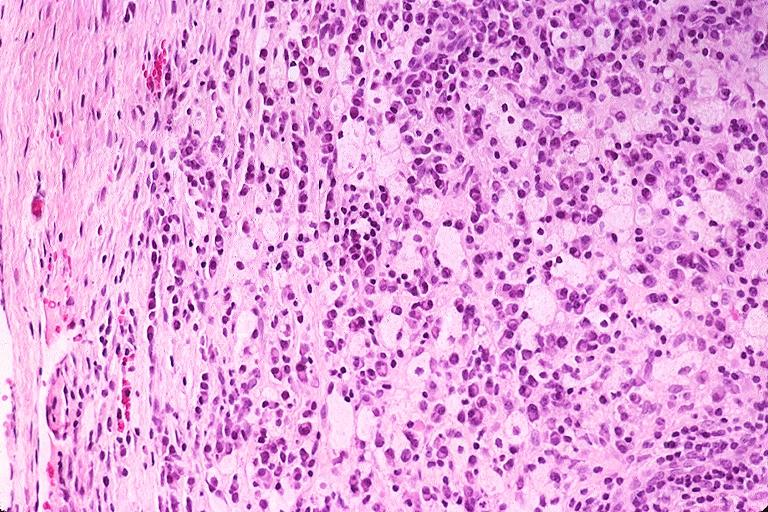does postpartum uterus show periapical granuloma?
Answer the question using a single word or phrase. No 